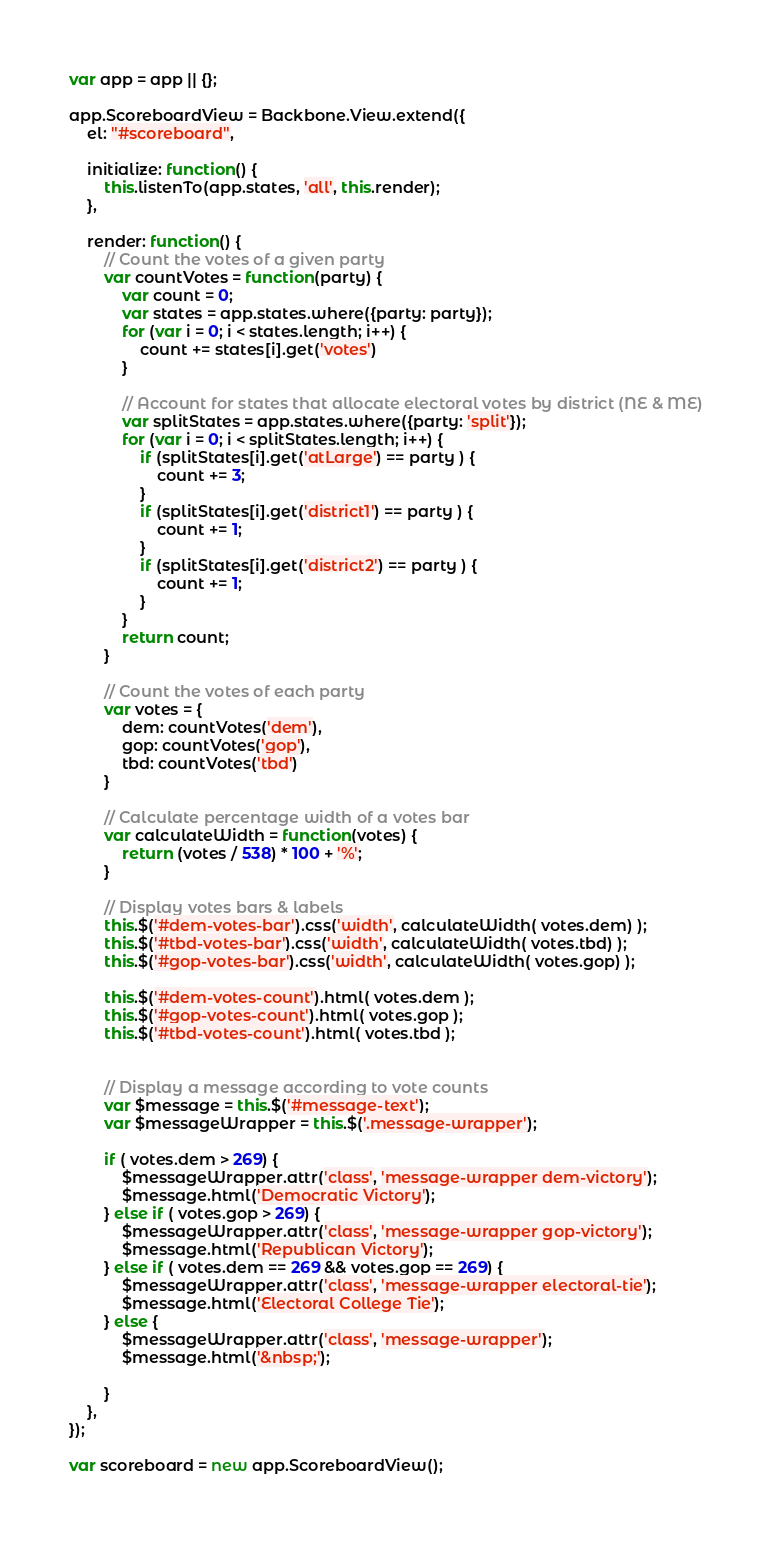Convert code to text. <code><loc_0><loc_0><loc_500><loc_500><_JavaScript_>var app = app || {};

app.ScoreboardView = Backbone.View.extend({
	el: "#scoreboard",

	initialize: function() {
		this.listenTo(app.states, 'all', this.render);
	},

	render: function() {
		// Count the votes of a given party
		var countVotes = function(party) {
			var count = 0;
			var states = app.states.where({party: party});
			for (var i = 0; i < states.length; i++) {
				count += states[i].get('votes')
			}

			// Account for states that allocate electoral votes by district (NE & ME)
			var splitStates = app.states.where({party: 'split'});
			for (var i = 0; i < splitStates.length; i++) {
				if (splitStates[i].get('atLarge') == party ) {
					count += 3;
				}
				if (splitStates[i].get('district1') == party ) {
					count += 1;
				}
				if (splitStates[i].get('district2') == party ) {
					count += 1;
				}
			}
			return count;
		}

		// Count the votes of each party
		var votes = {
			dem: countVotes('dem'),
			gop: countVotes('gop'),
			tbd: countVotes('tbd')
		}

		// Calculate percentage width of a votes bar
		var calculateWidth = function(votes) {
			return (votes / 538) * 100 + '%';
		}

		// Display votes bars & labels
		this.$('#dem-votes-bar').css('width', calculateWidth( votes.dem) );
		this.$('#tbd-votes-bar').css('width', calculateWidth( votes.tbd) );
		this.$('#gop-votes-bar').css('width', calculateWidth( votes.gop) );

		this.$('#dem-votes-count').html( votes.dem );
		this.$('#gop-votes-count').html( votes.gop );
		this.$('#tbd-votes-count').html( votes.tbd );

		
		// Display a message according to vote counts
		var $message = this.$('#message-text');
		var $messageWrapper = this.$('.message-wrapper');

		if ( votes.dem > 269) {
			$messageWrapper.attr('class', 'message-wrapper dem-victory');
			$message.html('Democratic Victory');
		} else if ( votes.gop > 269) {
			$messageWrapper.attr('class', 'message-wrapper gop-victory');
			$message.html('Republican Victory');
		} else if ( votes.dem == 269 && votes.gop == 269) {
			$messageWrapper.attr('class', 'message-wrapper electoral-tie');
			$message.html('Electoral College Tie');
		} else {
			$messageWrapper.attr('class', 'message-wrapper');
			$message.html('&nbsp;');
			
		}
	},
});

var scoreboard = new app.ScoreboardView();</code> 